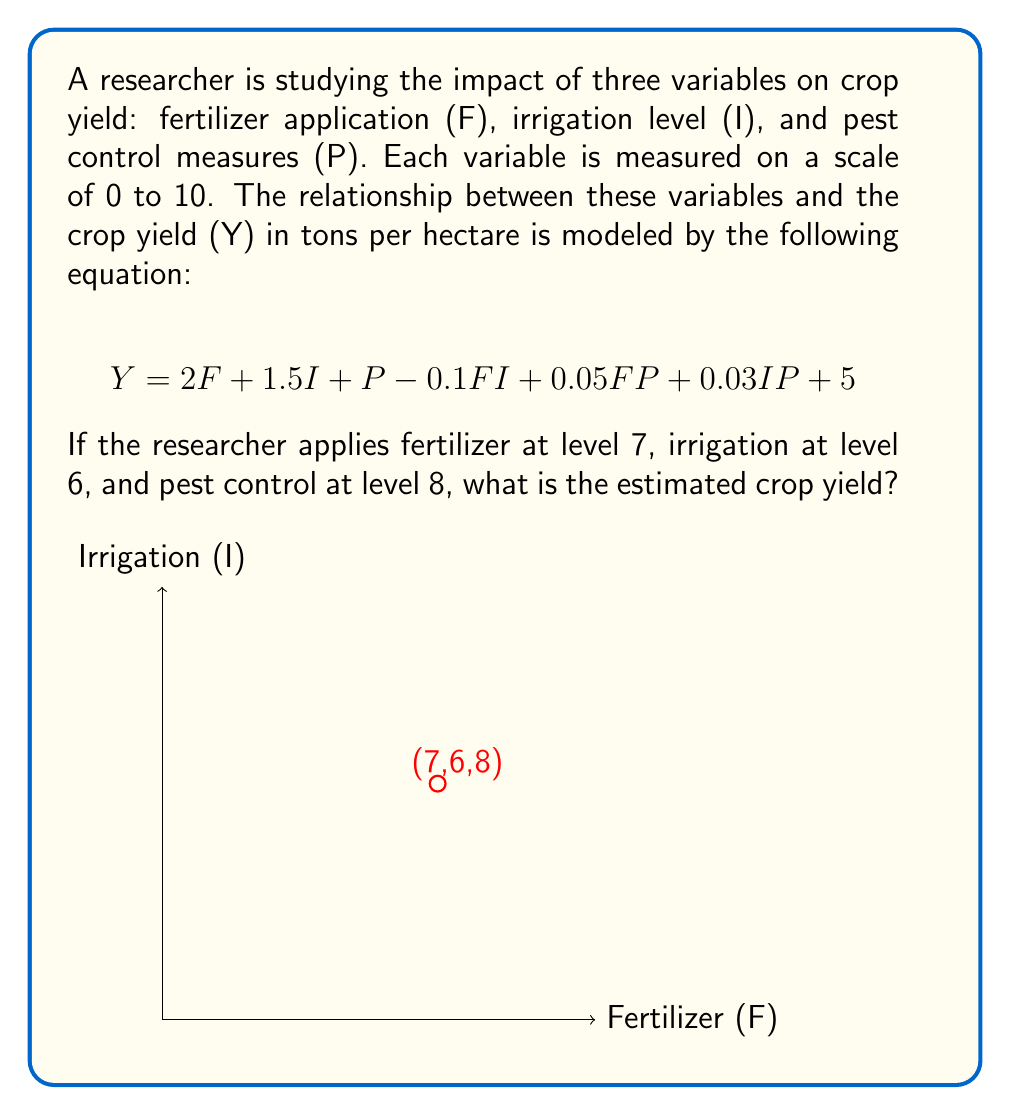Help me with this question. Let's solve this problem step by step:

1) We are given the equation:
   $$Y = 2F + 1.5I + P - 0.1FI + 0.05FP + 0.03IP + 5$$

2) We need to substitute the values:
   F = 7 (Fertilizer level)
   I = 6 (Irrigation level)
   P = 8 (Pest control level)

3) Let's substitute these values into the equation:
   $$Y = 2(7) + 1.5(6) + 8 - 0.1(7)(6) + 0.05(7)(8) + 0.03(6)(8) + 5$$

4) Now, let's calculate each term:
   - $2F = 2(7) = 14$
   - $1.5I = 1.5(6) = 9$
   - $P = 8$
   - $-0.1FI = -0.1(7)(6) = -4.2$
   - $0.05FP = 0.05(7)(8) = 2.8$
   - $0.03IP = 0.03(6)(8) = 1.44$
   - The constant term is 5

5) Sum up all these terms:
   $$Y = 14 + 9 + 8 - 4.2 + 2.8 + 1.44 + 5$$

6) Calculate the final result:
   $$Y = 36.04$$

Therefore, the estimated crop yield is 36.04 tons per hectare.
Answer: 36.04 tons per hectare 